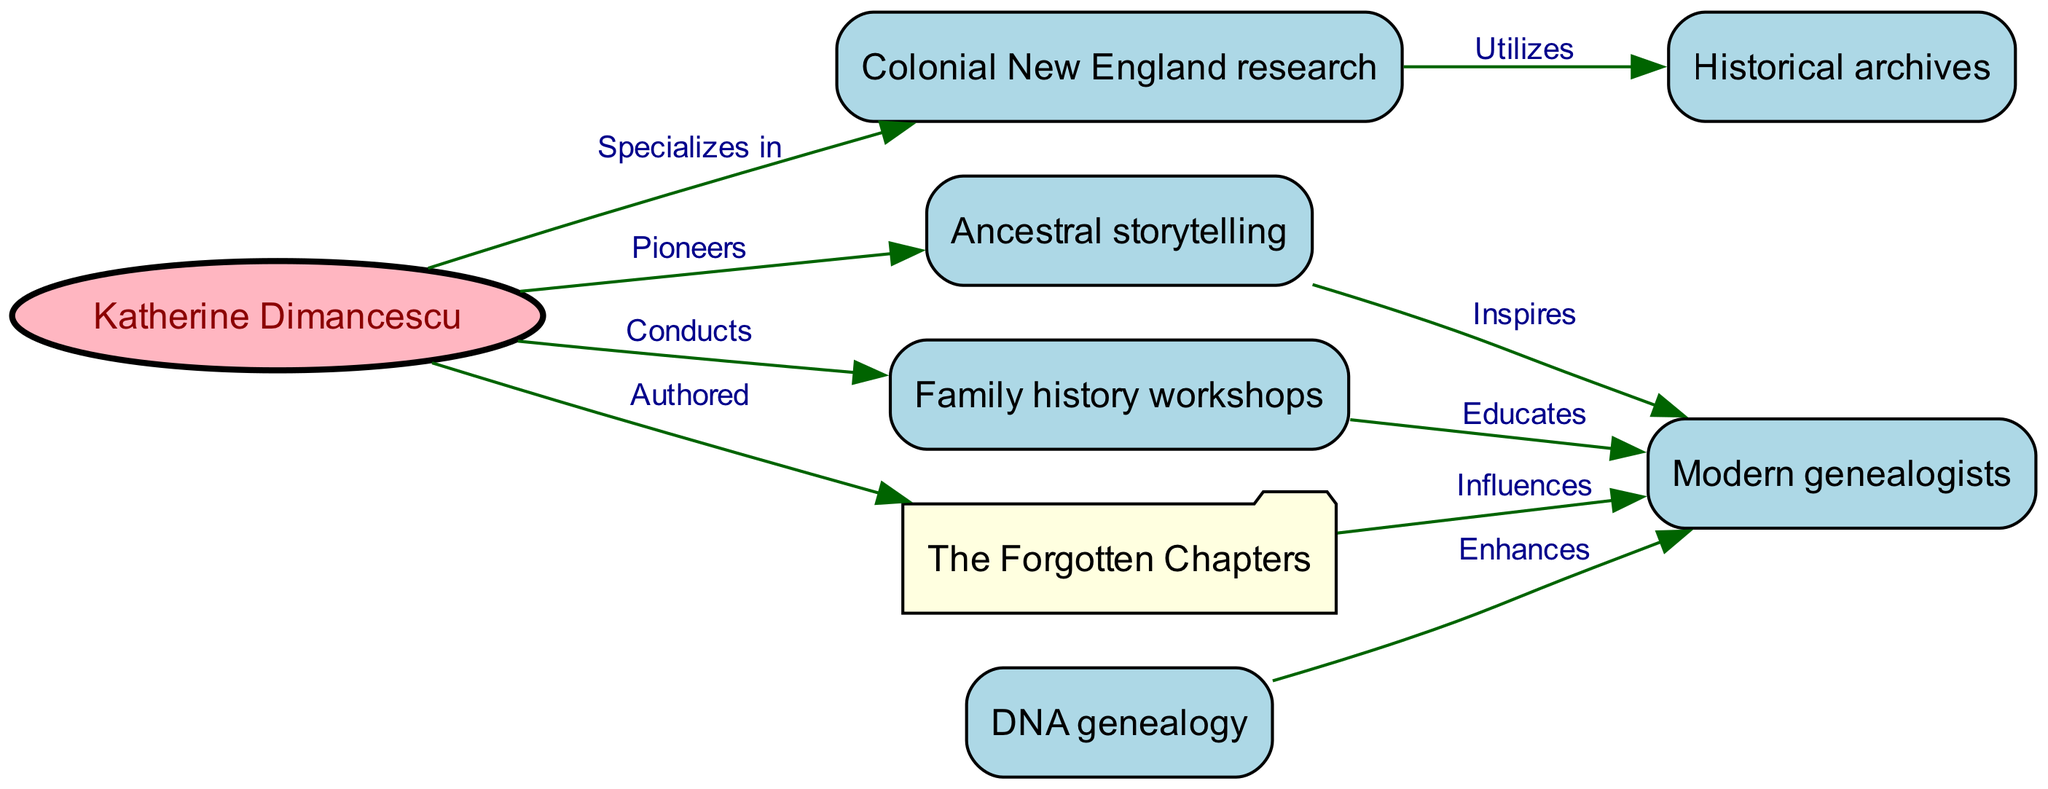What is the total number of nodes in the diagram? The diagram contains 8 unique nodes. This count includes Katherine Dimancescu, Colonial New England research, Ancestral storytelling, DNA genealogy, Historical archives, Family history workshops, The Forgotten Chapters, and Modern genealogists.
Answer: 8 Who authored "The Forgotten Chapters"? The directed edge from Katherine Dimancescu to The Forgotten Chapters indicates that she is the author.
Answer: Katherine Dimancescu What is the role of Family history workshops in the context of modern genealogists? There is an edge leading from Family history workshops to Modern genealogists labeled "Educates," indicating that the workshops serve an educational function for modern genealogists.
Answer: Educates How does Katherine Dimancescu influence modern genealogists? Katherine Dimancescu has direct influences on modern genealogists through several edges: she pioneers ancestral storytelling, conducts family history workshops that educate them, and has authored "The Forgotten Chapters," which also influences them. These contributions together highlight her significant impact on modern genealogy.
Answer: Pioneers/Conducts/Influences Which research area utilizes historical archives? There is a directed edge from Colonial New England research to Historical archives, signifying that Colonial New England research makes use of historical archives in its methodologies.
Answer: Colonial New England research What are the three areas that inspire and enhance modern genealogists? The diagram shows that Ancestral storytelling inspires modern genealogists, while DNA genealogy enhances their research. Combined, these two areas significantly contribute to the development of modern genealogical practices.
Answer: Ancestral storytelling/DNA genealogy What type of resource is "The Forgotten Chapters"? In the diagram, "The Forgotten Chapters" is represented as an authored resource that influences modern genealogists, indicating its significance as a written work impacting their research approaches.
Answer: Authored How does DNA genealogy impact modern genealogists? The direct edge indicates that DNA genealogy enhances modern genealogists, suggesting it provides additional resources or methodologies to improve their research efforts.
Answer: Enhances Which node has the most direct connections overall? Analyzing the connections (or edges) from each node, Katherine Dimancescu has the most direct connections. She connects to Colonial New England research, Ancestral storytelling, The Forgotten Chapters, and Family history workshops, indicating she plays a pivotal role in the diagram.
Answer: Katherine Dimancescu 